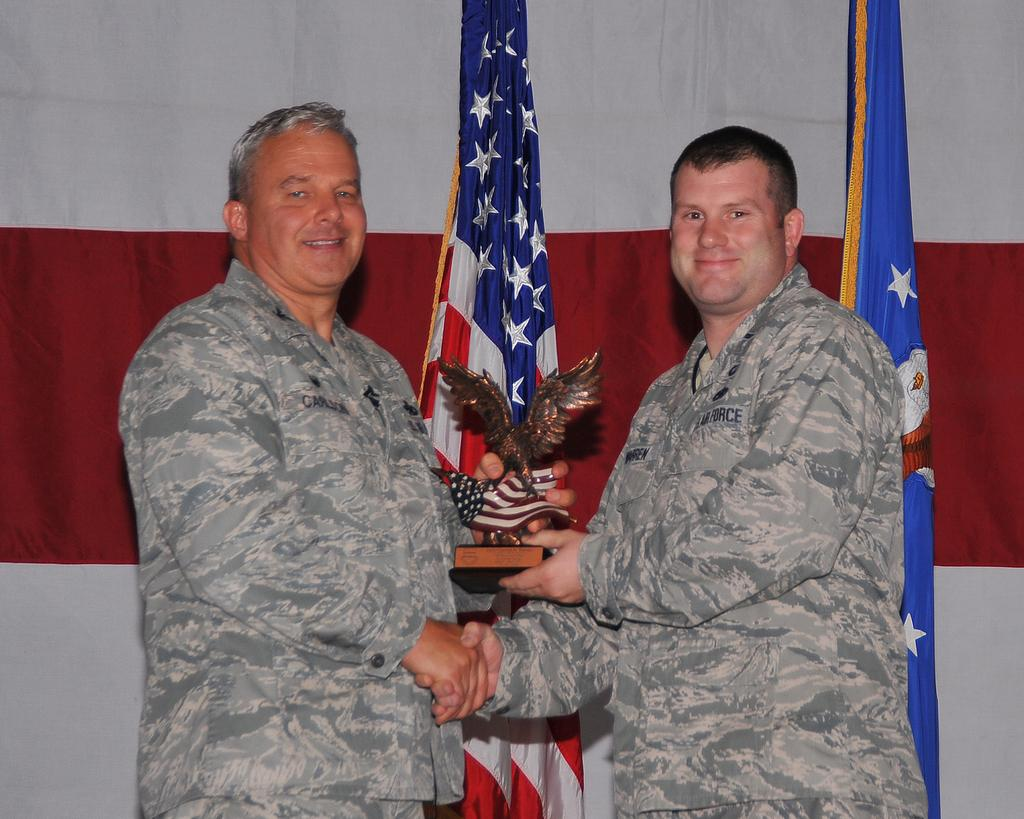What are the men in the image doing with their hands? The men are shaking hands with one hand and holding a trophy with their other hand. What can be seen in the background of the image? There are flags visible in the background of the image. What type of street art can be seen on the walls in the image? There is no street art present in the image; it features men shaking hands and holding a trophy. How many copies of the trophy are visible in the image? There is only one trophy visible in the image, and it is being held by one of the men. 